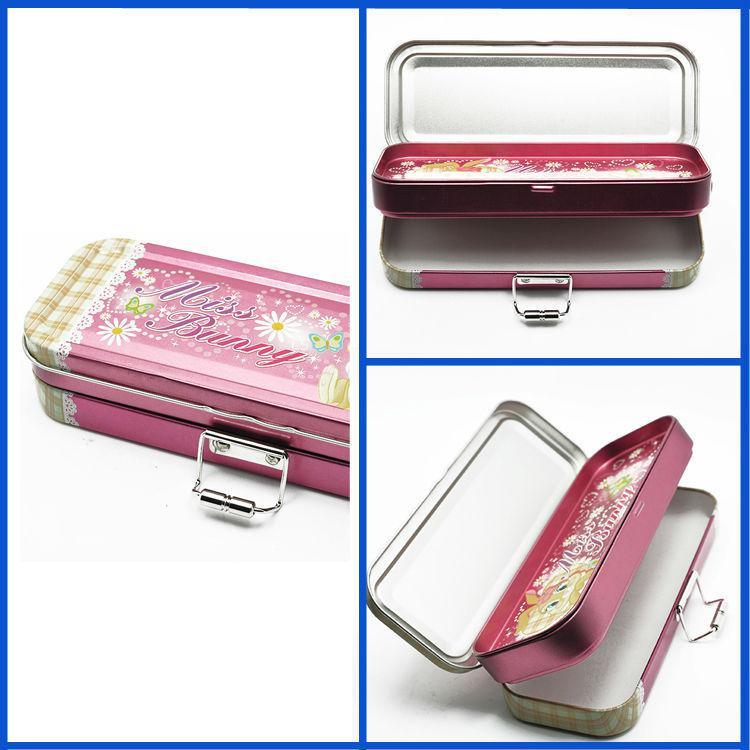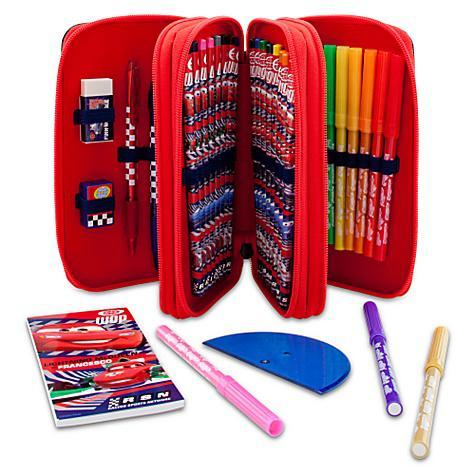The first image is the image on the left, the second image is the image on the right. Assess this claim about the two images: "One image shows a filled box-shaped pink pencil case with a flip-up lid, and the other image shows several versions of closed cases with cartoon creatures on the fronts.". Correct or not? Answer yes or no. No. 